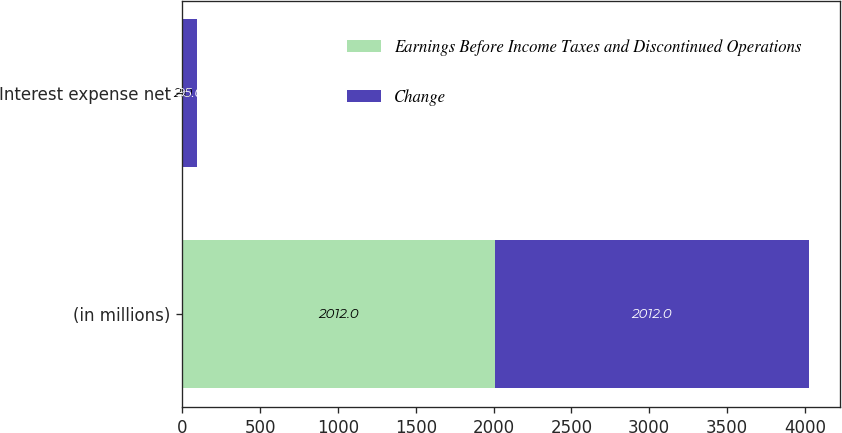Convert chart. <chart><loc_0><loc_0><loc_500><loc_500><stacked_bar_chart><ecel><fcel>(in millions)<fcel>Interest expense net<nl><fcel>Earnings Before Income Taxes and Discontinued Operations<fcel>2012<fcel>2<nl><fcel>Change<fcel>2012<fcel>95<nl></chart> 